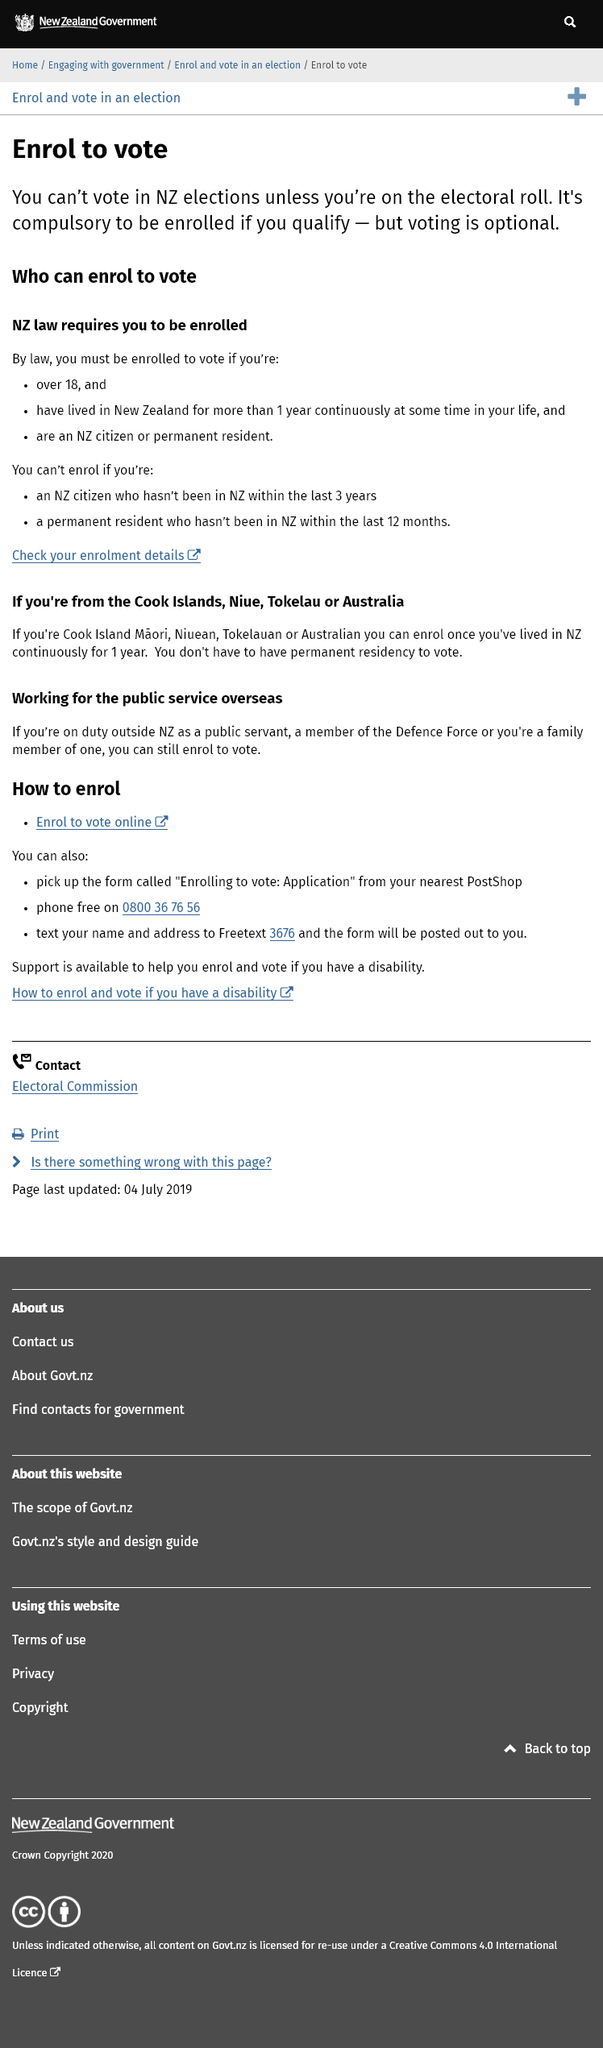Identify some key points in this picture. It is not possible to vote in New Zealand elections if you are not registered on the electoral roll. Voting is not compulsory in any way. It is entirely optional for individuals to participate in the democratic process by casting their vote. You cannot enroll to vote if you are a New Zealand citizen who has not been in the country within the past 3 years. 